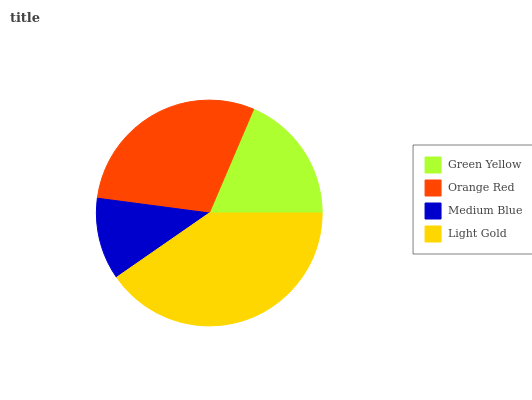Is Medium Blue the minimum?
Answer yes or no. Yes. Is Light Gold the maximum?
Answer yes or no. Yes. Is Orange Red the minimum?
Answer yes or no. No. Is Orange Red the maximum?
Answer yes or no. No. Is Orange Red greater than Green Yellow?
Answer yes or no. Yes. Is Green Yellow less than Orange Red?
Answer yes or no. Yes. Is Green Yellow greater than Orange Red?
Answer yes or no. No. Is Orange Red less than Green Yellow?
Answer yes or no. No. Is Orange Red the high median?
Answer yes or no. Yes. Is Green Yellow the low median?
Answer yes or no. Yes. Is Light Gold the high median?
Answer yes or no. No. Is Light Gold the low median?
Answer yes or no. No. 